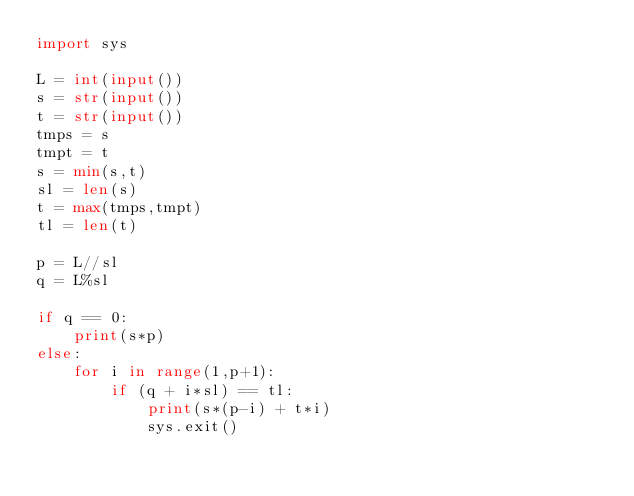Convert code to text. <code><loc_0><loc_0><loc_500><loc_500><_Python_>import sys

L = int(input())
s = str(input())
t = str(input())
tmps = s
tmpt = t
s = min(s,t)
sl = len(s)
t = max(tmps,tmpt)
tl = len(t)

p = L//sl
q = L%sl

if q == 0:
    print(s*p)
else:
    for i in range(1,p+1):
        if (q + i*sl) == tl:
            print(s*(p-i) + t*i)
            sys.exit()</code> 